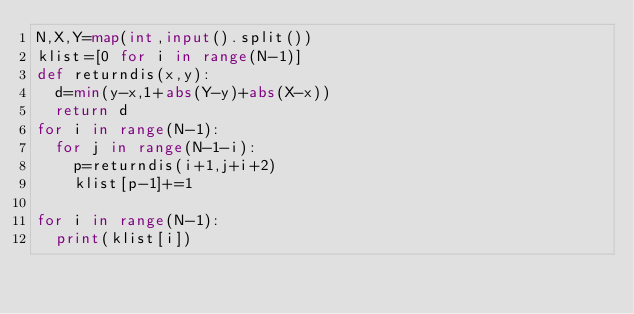Convert code to text. <code><loc_0><loc_0><loc_500><loc_500><_Python_>N,X,Y=map(int,input().split())
klist=[0 for i in range(N-1)]
def returndis(x,y):
  d=min(y-x,1+abs(Y-y)+abs(X-x))
  return d
for i in range(N-1):
  for j in range(N-1-i):
    p=returndis(i+1,j+i+2)
    klist[p-1]+=1

for i in range(N-1):
  print(klist[i])</code> 